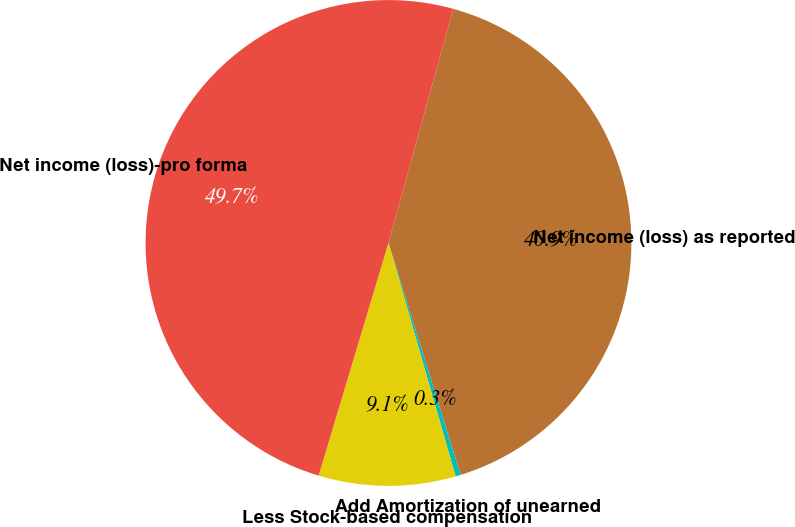Convert chart to OTSL. <chart><loc_0><loc_0><loc_500><loc_500><pie_chart><fcel>Net income (loss) as reported<fcel>Add Amortization of unearned<fcel>Less Stock-based compensation<fcel>Net income (loss)-pro forma<nl><fcel>40.9%<fcel>0.35%<fcel>9.1%<fcel>49.65%<nl></chart> 